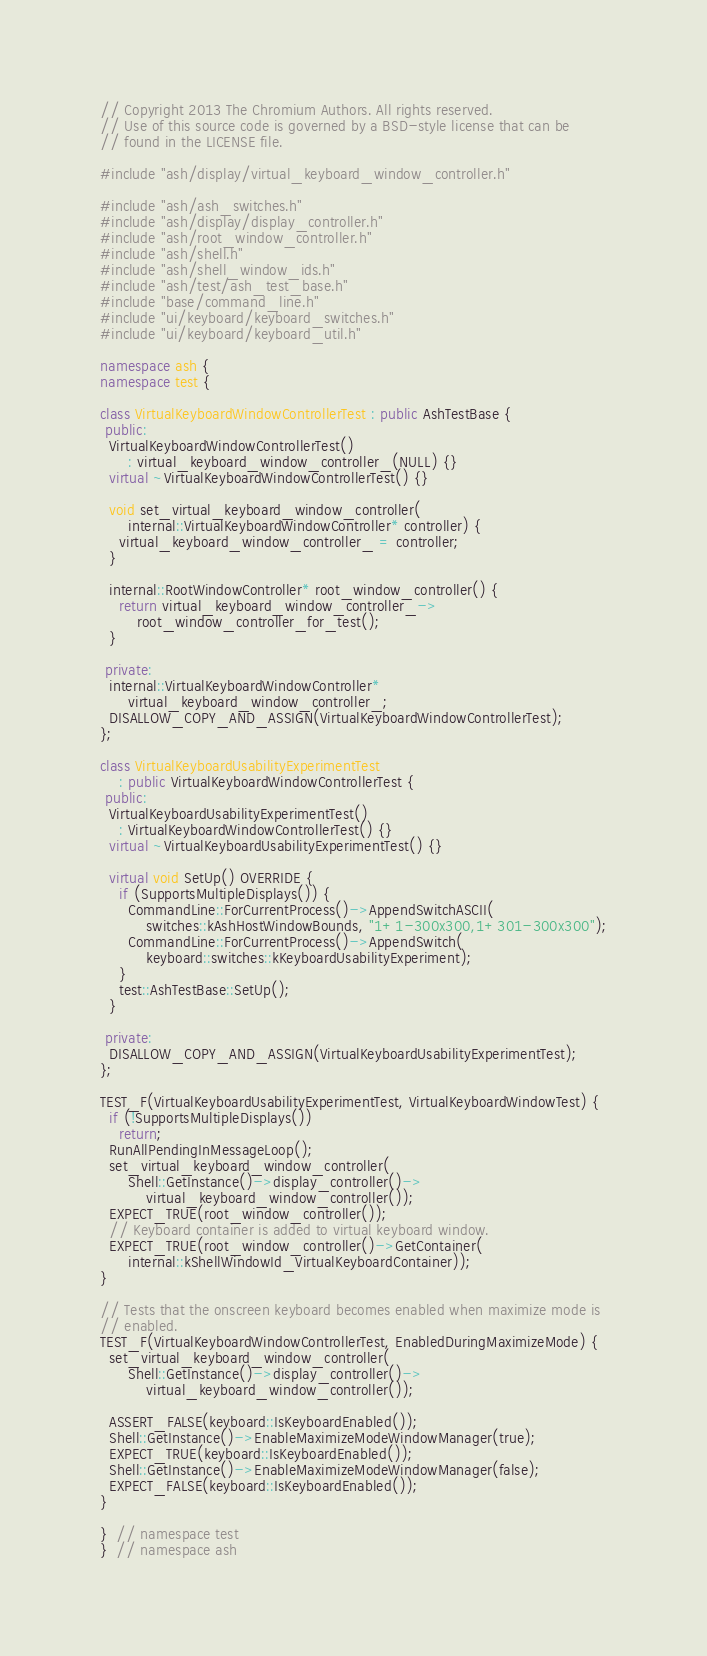<code> <loc_0><loc_0><loc_500><loc_500><_C++_>// Copyright 2013 The Chromium Authors. All rights reserved.
// Use of this source code is governed by a BSD-style license that can be
// found in the LICENSE file.

#include "ash/display/virtual_keyboard_window_controller.h"

#include "ash/ash_switches.h"
#include "ash/display/display_controller.h"
#include "ash/root_window_controller.h"
#include "ash/shell.h"
#include "ash/shell_window_ids.h"
#include "ash/test/ash_test_base.h"
#include "base/command_line.h"
#include "ui/keyboard/keyboard_switches.h"
#include "ui/keyboard/keyboard_util.h"

namespace ash {
namespace test {

class VirtualKeyboardWindowControllerTest : public AshTestBase {
 public:
  VirtualKeyboardWindowControllerTest()
      : virtual_keyboard_window_controller_(NULL) {}
  virtual ~VirtualKeyboardWindowControllerTest() {}

  void set_virtual_keyboard_window_controller(
      internal::VirtualKeyboardWindowController* controller) {
    virtual_keyboard_window_controller_ = controller;
  }

  internal::RootWindowController* root_window_controller() {
    return virtual_keyboard_window_controller_->
        root_window_controller_for_test();
  }

 private:
  internal::VirtualKeyboardWindowController*
      virtual_keyboard_window_controller_;
  DISALLOW_COPY_AND_ASSIGN(VirtualKeyboardWindowControllerTest);
};

class VirtualKeyboardUsabilityExperimentTest
    : public VirtualKeyboardWindowControllerTest {
 public:
  VirtualKeyboardUsabilityExperimentTest()
    : VirtualKeyboardWindowControllerTest() {}
  virtual ~VirtualKeyboardUsabilityExperimentTest() {}

  virtual void SetUp() OVERRIDE {
    if (SupportsMultipleDisplays()) {
      CommandLine::ForCurrentProcess()->AppendSwitchASCII(
          switches::kAshHostWindowBounds, "1+1-300x300,1+301-300x300");
      CommandLine::ForCurrentProcess()->AppendSwitch(
          keyboard::switches::kKeyboardUsabilityExperiment);
    }
    test::AshTestBase::SetUp();
  }

 private:
  DISALLOW_COPY_AND_ASSIGN(VirtualKeyboardUsabilityExperimentTest);
};

TEST_F(VirtualKeyboardUsabilityExperimentTest, VirtualKeyboardWindowTest) {
  if (!SupportsMultipleDisplays())
    return;
  RunAllPendingInMessageLoop();
  set_virtual_keyboard_window_controller(
      Shell::GetInstance()->display_controller()->
          virtual_keyboard_window_controller());
  EXPECT_TRUE(root_window_controller());
  // Keyboard container is added to virtual keyboard window.
  EXPECT_TRUE(root_window_controller()->GetContainer(
      internal::kShellWindowId_VirtualKeyboardContainer));
}

// Tests that the onscreen keyboard becomes enabled when maximize mode is
// enabled.
TEST_F(VirtualKeyboardWindowControllerTest, EnabledDuringMaximizeMode) {
  set_virtual_keyboard_window_controller(
      Shell::GetInstance()->display_controller()->
          virtual_keyboard_window_controller());

  ASSERT_FALSE(keyboard::IsKeyboardEnabled());
  Shell::GetInstance()->EnableMaximizeModeWindowManager(true);
  EXPECT_TRUE(keyboard::IsKeyboardEnabled());
  Shell::GetInstance()->EnableMaximizeModeWindowManager(false);
  EXPECT_FALSE(keyboard::IsKeyboardEnabled());
}

}  // namespace test
}  // namespace ash
</code> 